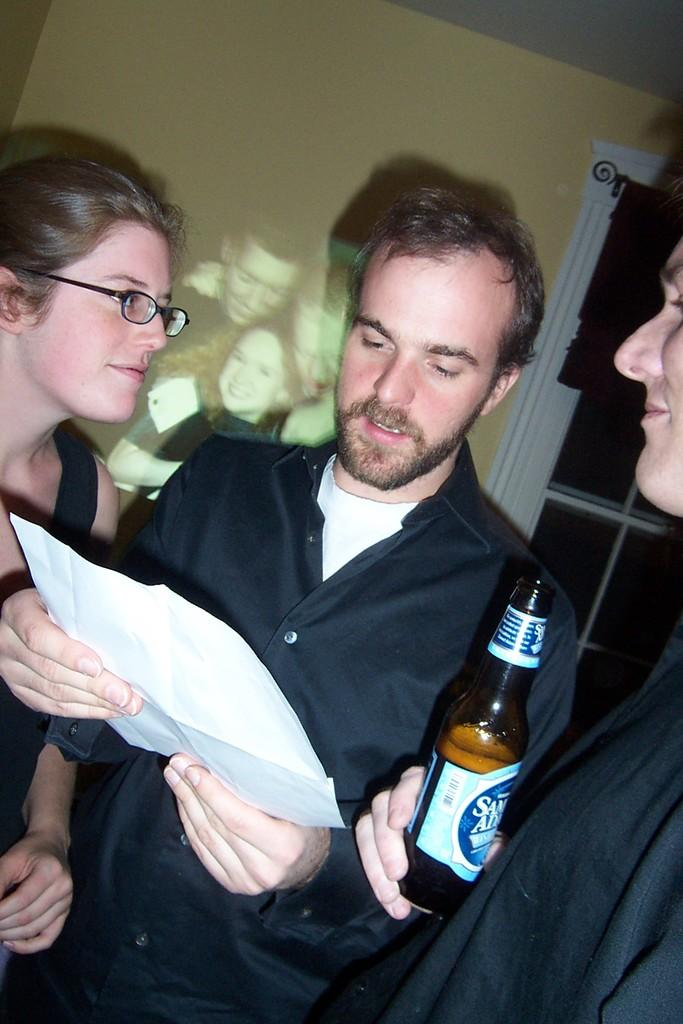How many people are in the image? There are three persons in the image. What is the person in the middle holding? The person in the middle is holding a paper. What is the person at the right side holding? The person at the right side is holding a bottle. What can be seen in the background of the image? There is a window visible in the background of the image. What type of cap can be seen on the person at the left side of the image? There is no person at the left side of the image, and therefore no cap is visible. Can you tell me how many trucks are parked outside the window in the image? There is no information about trucks or a park in the image, so we cannot determine if any trucks are parked outside the window. 